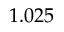<formula> <loc_0><loc_0><loc_500><loc_500>1 . 0 2 5</formula> 